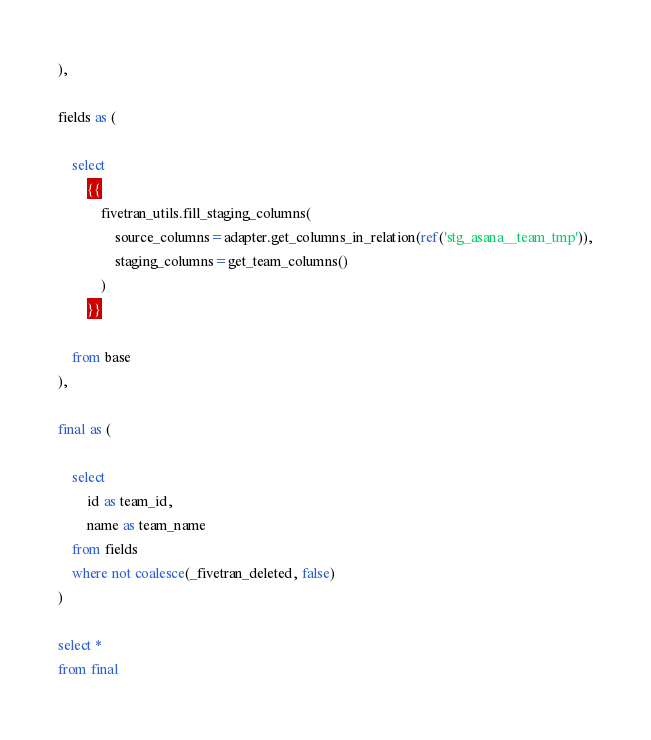<code> <loc_0><loc_0><loc_500><loc_500><_SQL_>
),

fields as (

    select
        {{
            fivetran_utils.fill_staging_columns(
                source_columns=adapter.get_columns_in_relation(ref('stg_asana__team_tmp')),
                staging_columns=get_team_columns()
            )
        }}
        
    from base
),

final as (
    
    select 
        id as team_id,
        name as team_name
    from fields
    where not coalesce(_fivetran_deleted, false)
)

select * 
from final
</code> 